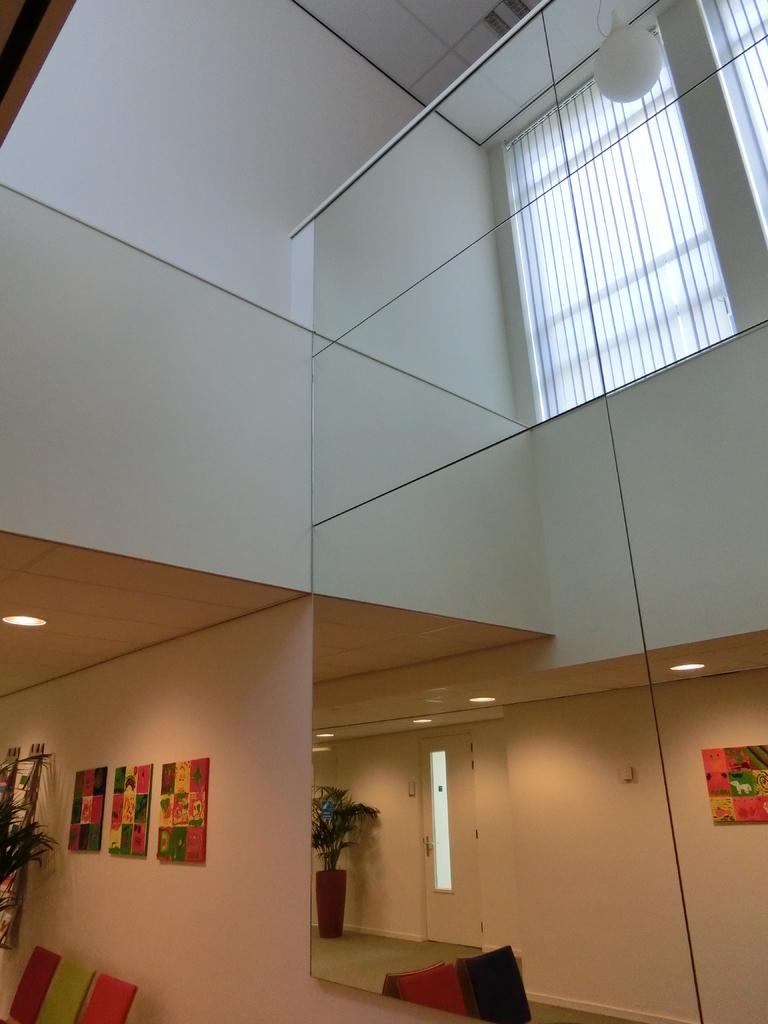What type of structure is visible in the image? There is a building in the image. What feature can be seen on the building? The building has a window. What type of furniture is present in the image? There are chairs in the image. What type of plant is visible in the image? There is a plant in a pot in the image. What type of decoration is on the walls in the image? There are frames on the walls in the image. What type of entrance is visible in the image? There is a door in the image. What type of lighting is present in the building? There are ceiling lights in the image. What type of outdoor lighting is visible in the image? There is a lamp on the roof in the image. What type of butter is spread on the frames in the image? There is no butter present in the image; the frames are simply decorations on the walls. 